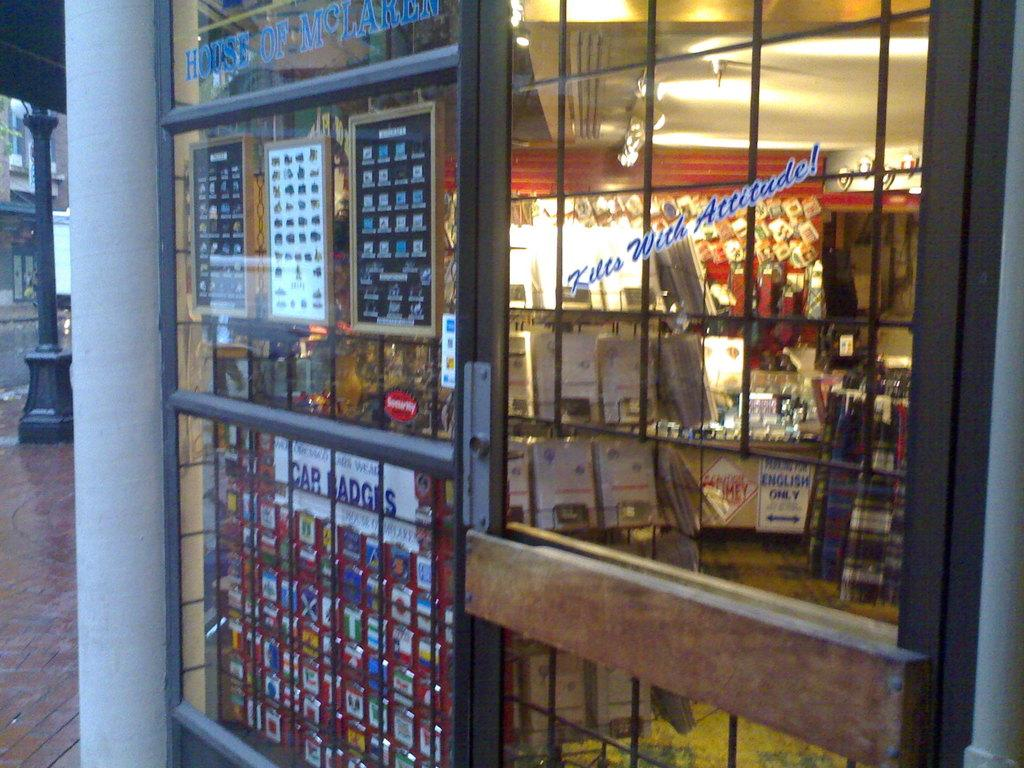<image>
Give a short and clear explanation of the subsequent image. White Car Badges sign in front of a  fenced store. 